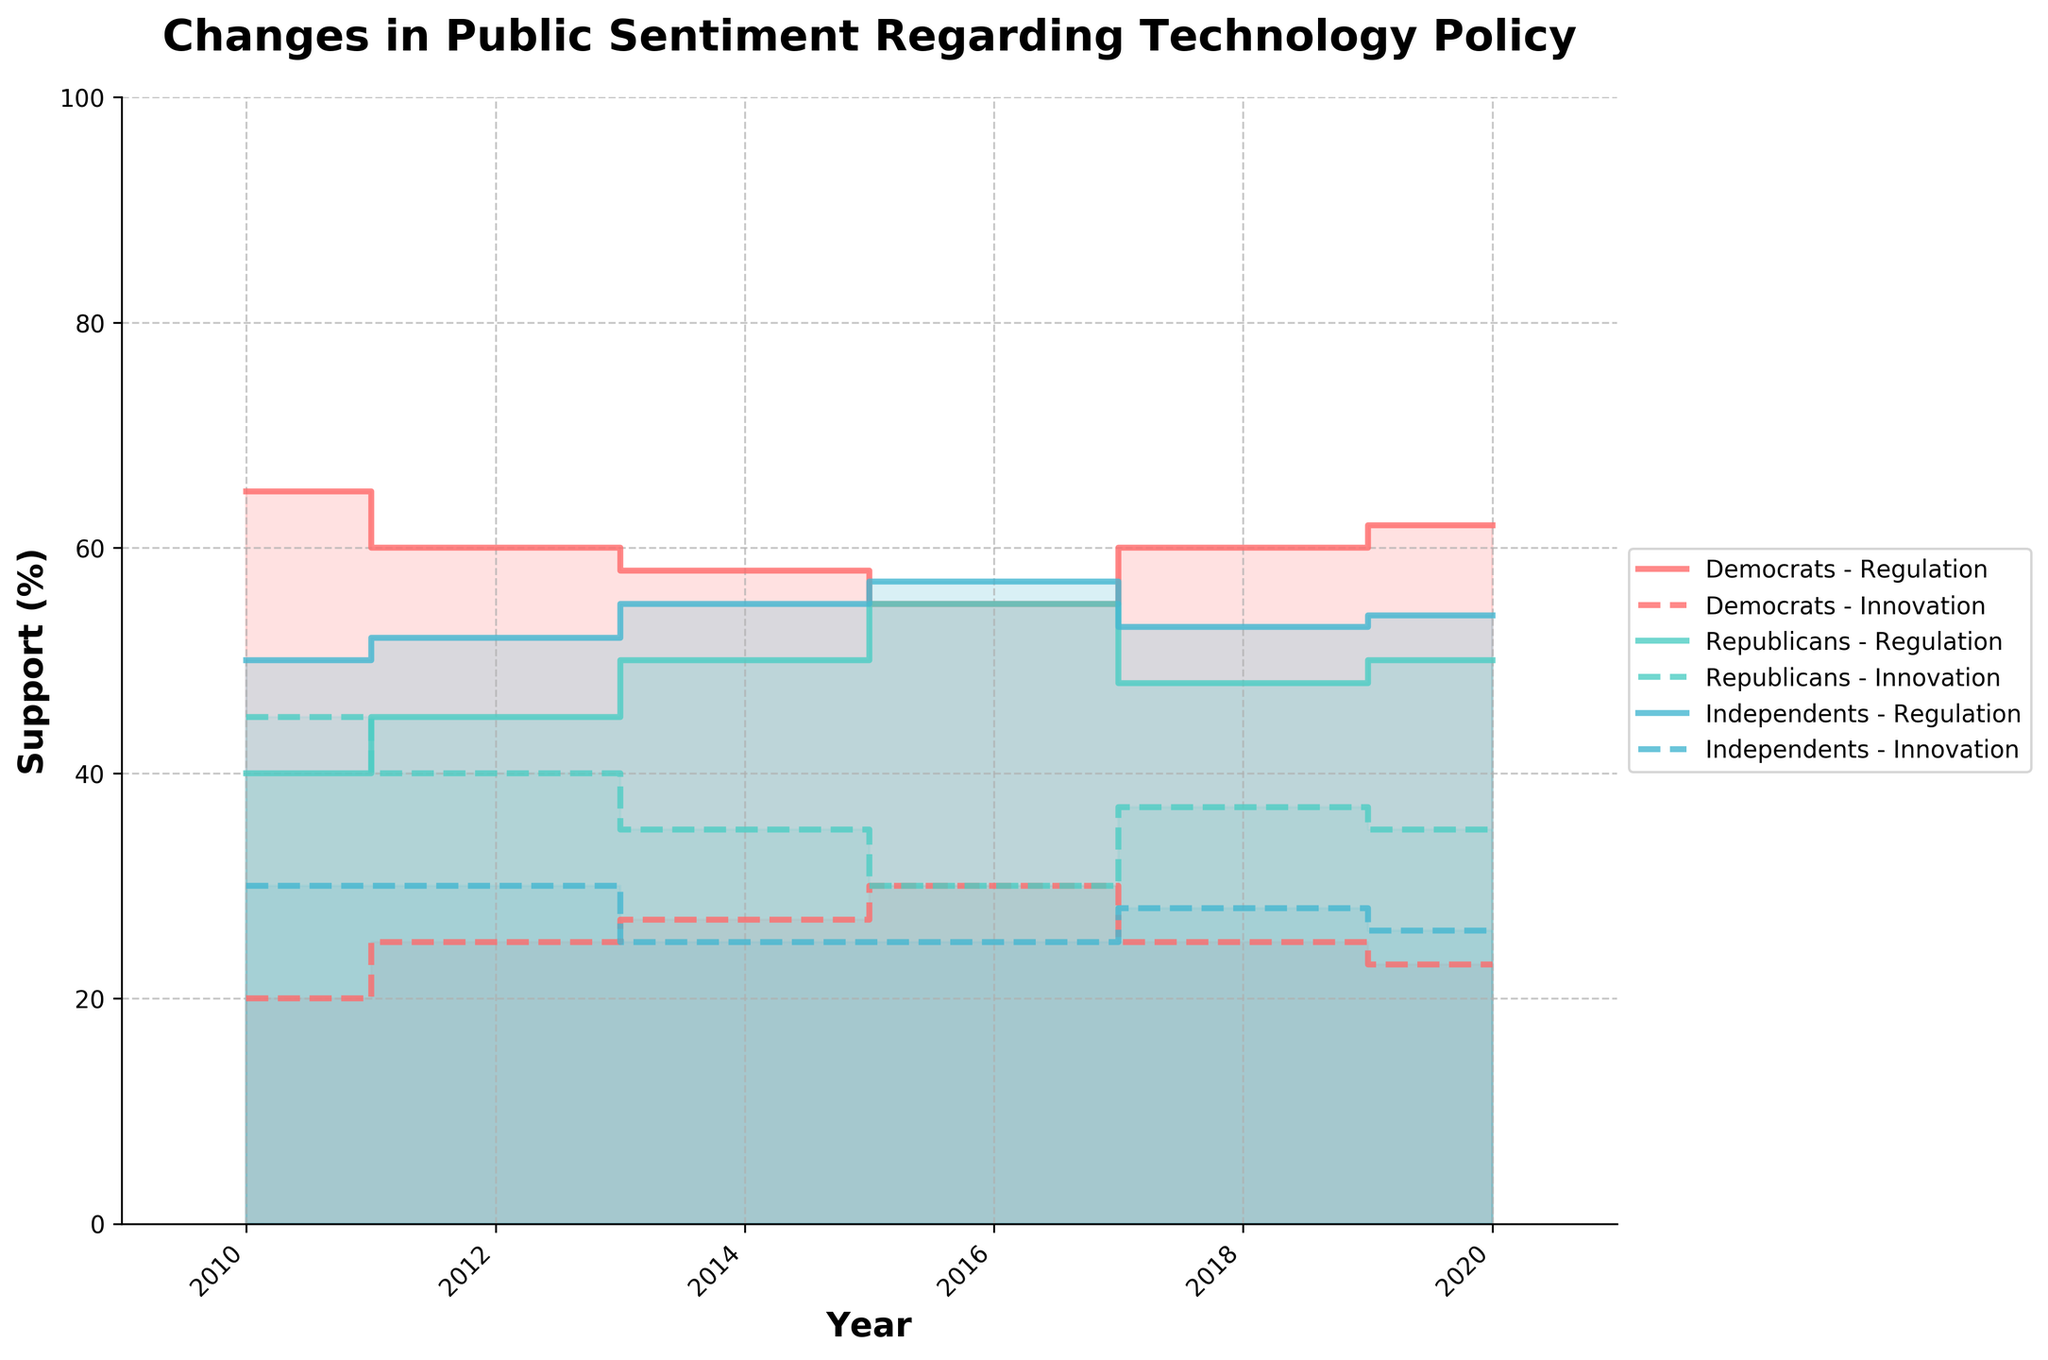How has the Democratic support for regulation changed from 2010 to 2020? The step area chart shows the trend in Democratic support for regulation from 2010 to 2020. In 2010, support was at 65%, which dropped to 60% in 2012, then to 58% in 2014. It decreased further to 55% in 2016 before rising to 60% in 2018 and 62% in 2020.
Answer: Increased by 3 percentage points Which political affiliation had the highest support for innovation in 2018? By examining the dashed lines in the 2018 segment of the chart, the Republican support stands out, reaching 37%. Democrats and Independents show lower percentages.
Answer: Republicans What is the difference in support for innovation between Republicans and Democrats in 2016? The chart indicates that in 2016, both Republicans and Democrats had identical support for innovation, each with 30%.
Answer: 0% Which year had the highest combined support for regulation among all political affiliations? Sum the support for regulation across all political affiliations for each year. For 2010, it’s 65 + 40 + 50 = 155. For 2012, it’s 60 + 45 + 52 = 157. For 2014, it’s 58 + 50 + 55 = 163. For 2016, it’s 55 + 55 + 57 = 167. For 2018, it’s 60 + 48 + 53 = 161. For 2020, it’s 62 + 50 + 54 = 166. The highest is in 2016 with 167.
Answer: 2016 How did Independent support for regulation change between 2010 and 2014? Independent support for regulation increased from 50% in 2010 to 52% in 2012, reaching 55% in 2014.
Answer: Increased by 5 percentage points Which political group showed the most neutral stance consistently over the years? The neutral percentage remains at 15% consistently across all years for both Democrats and Republicans. Independents display variances, fluctuating between 18% to 20%. Thus, Republicans and Democrats are equally consistent.
Answer: Democrats and Republicans What general trend is observable in Republican support for technology policy from 2010 to 2020? By analyzing the chart, Republican support for regulation generally shows an upward trend: 40% in 2010, rising to 45% in 2012, 50% in 2014, reaching 55% in 2016, slightly dropping to 48% in 2018, and then settling at 50% in 2020.
Answer: Increasing trend 